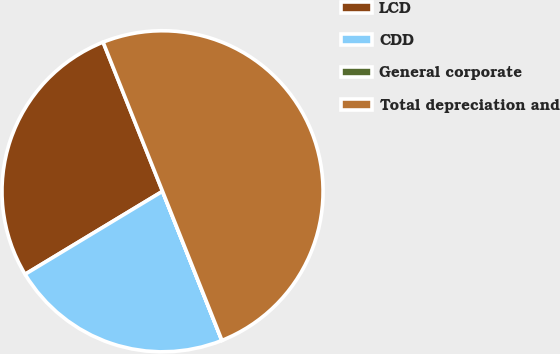Convert chart. <chart><loc_0><loc_0><loc_500><loc_500><pie_chart><fcel>LCD<fcel>CDD<fcel>General corporate<fcel>Total depreciation and<nl><fcel>27.61%<fcel>22.38%<fcel>0.01%<fcel>50.0%<nl></chart> 